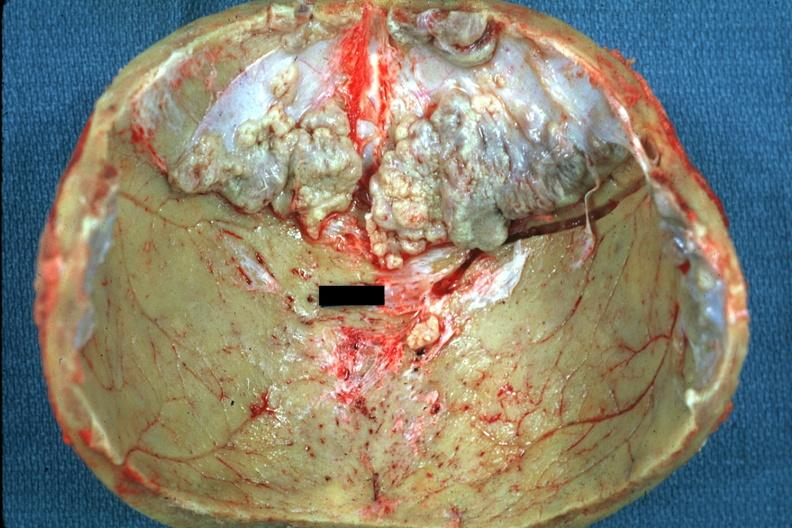does opened base of skull with brain show several rather large lesions?
Answer the question using a single word or phrase. No 